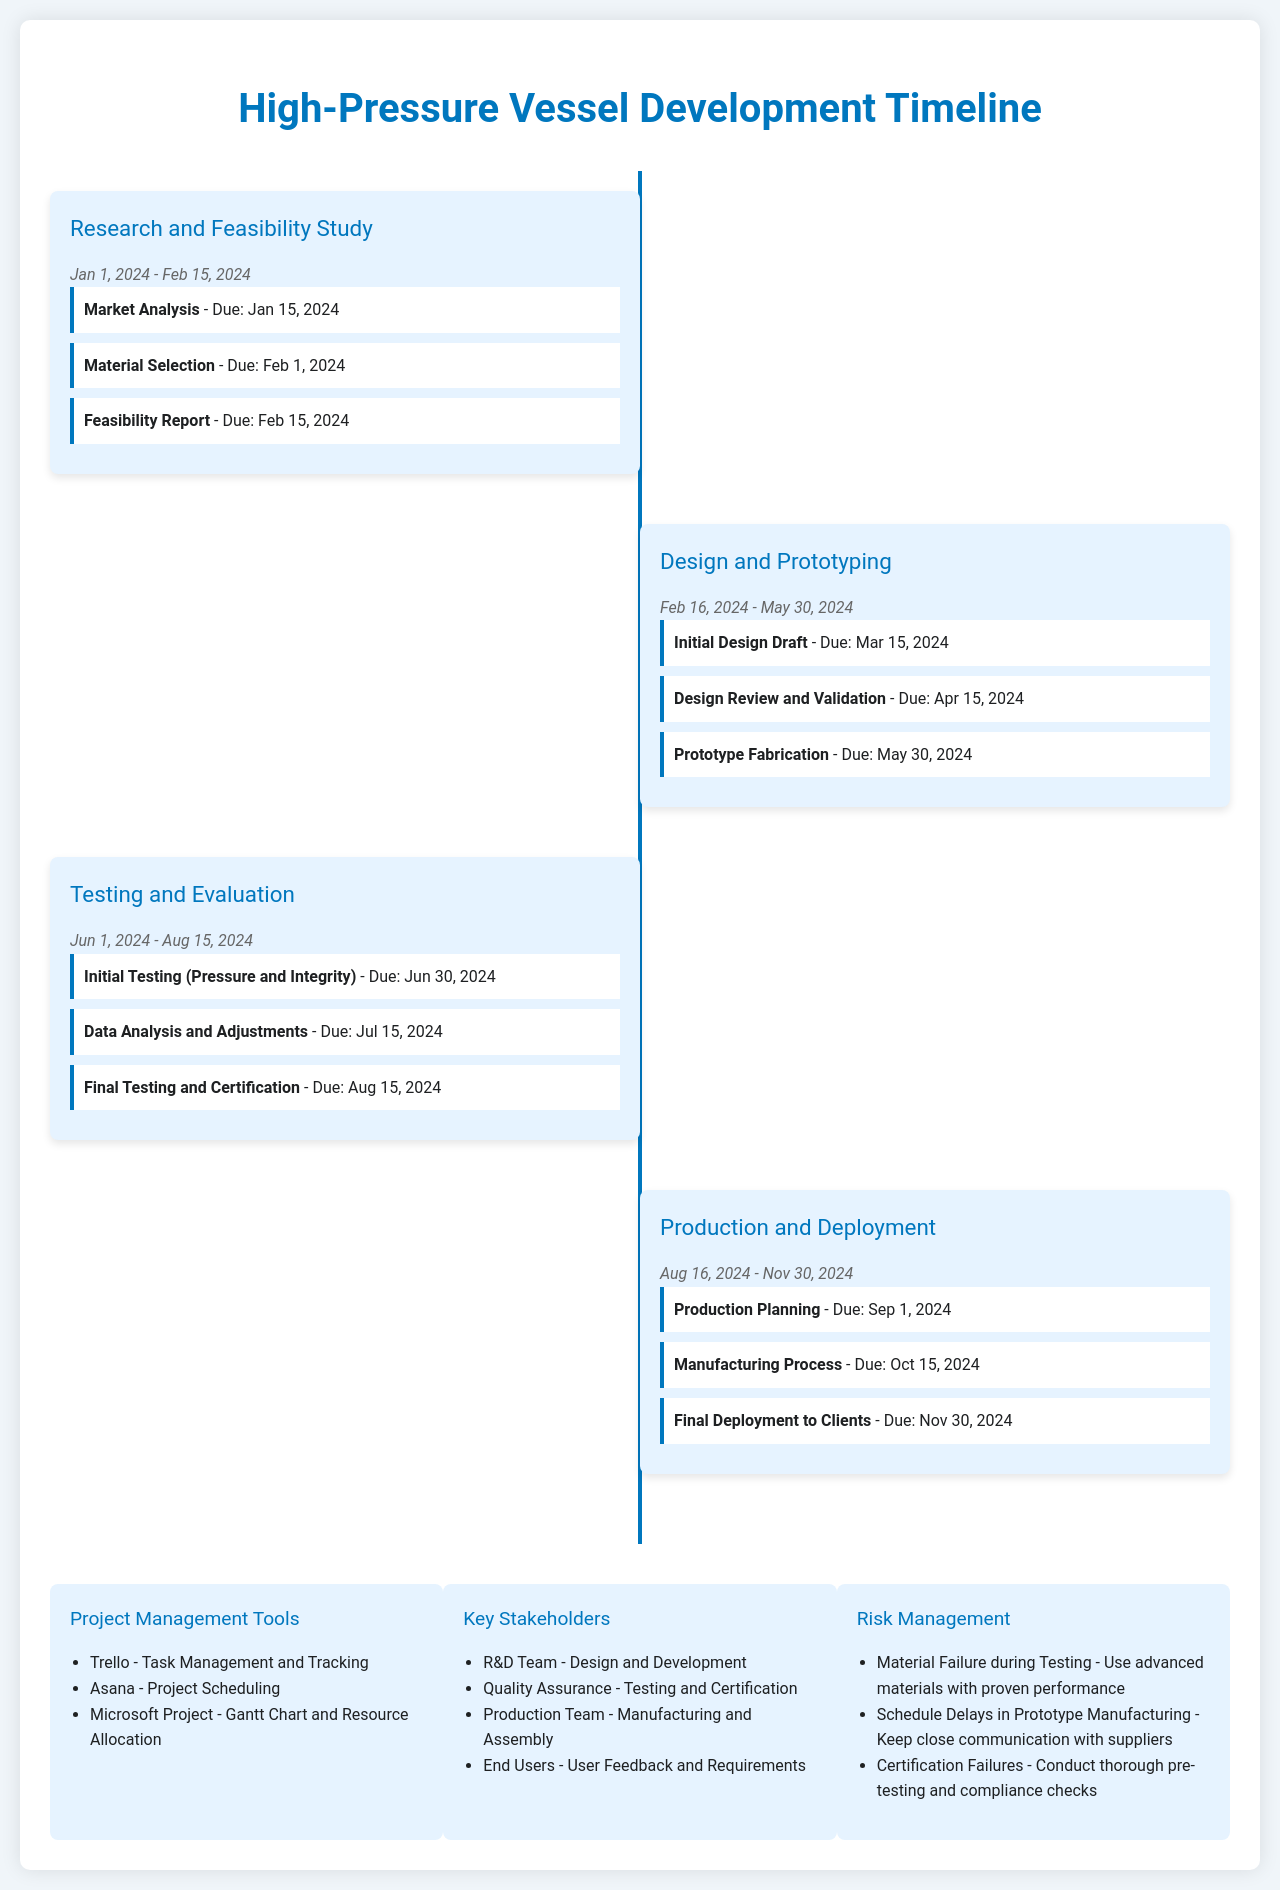What is the duration of the Research and Feasibility Study phase? The Research and Feasibility Study phase spans from January 1, 2024, to February 15, 2024, giving it a duration of 1.5 months.
Answer: Jan 1, 2024 - Feb 15, 2024 What is the due date for the Initial Design Draft? The Initial Design Draft milestone is due on March 15, 2024, as indicated in the Design and Prototyping phase.
Answer: Mar 15, 2024 What milestone is due on August 15, 2024? The Final Testing and Certification milestone in the Testing and Evaluation phase is due on that date.
Answer: Final Testing and Certification Which team is responsible for manufacturing and assembly? The document specifies that the Production Team is responsible for manufacturing and assembly activities.
Answer: Production Team How many milestones are in the Testing and Evaluation phase? There are three milestones listed in the Testing and Evaluation phase according to the document's timeline.
Answer: 3 What major deliverable follows the Design Review and Validation? The next major deliverable after the Design Review and Validation is the Prototype Fabrication.
Answer: Prototype Fabrication What tool is mentioned for task management and tracking? The document includes Trello as a tool for task management and tracking.
Answer: Trello What is a potential risk mentioned regarding certification? The document outlines Certification Failures as a potential risk during the project.
Answer: Certification Failures 